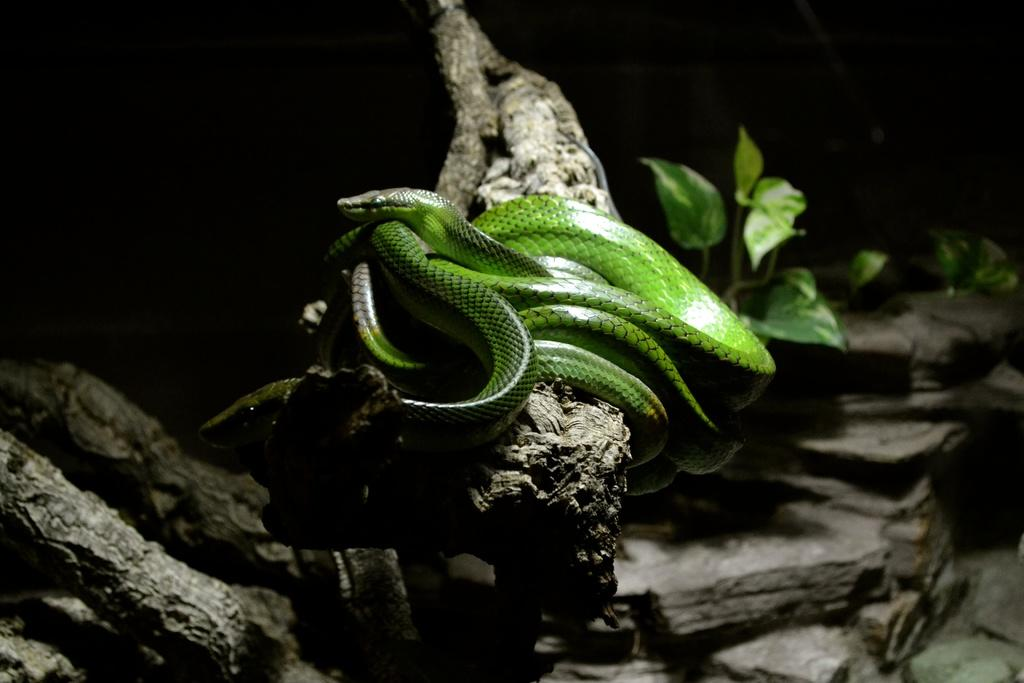What type of animal is in the image? There is a green snake in the image. Where is the snake located? The snake is on the branch of a tree. What else can be seen on the right side of the image? There is a plant on the right side of the image. What type of pen is the snake using to write on the volcano in the image? There is no pen or volcano present in the image; it features a green snake on a tree branch and a plant. 